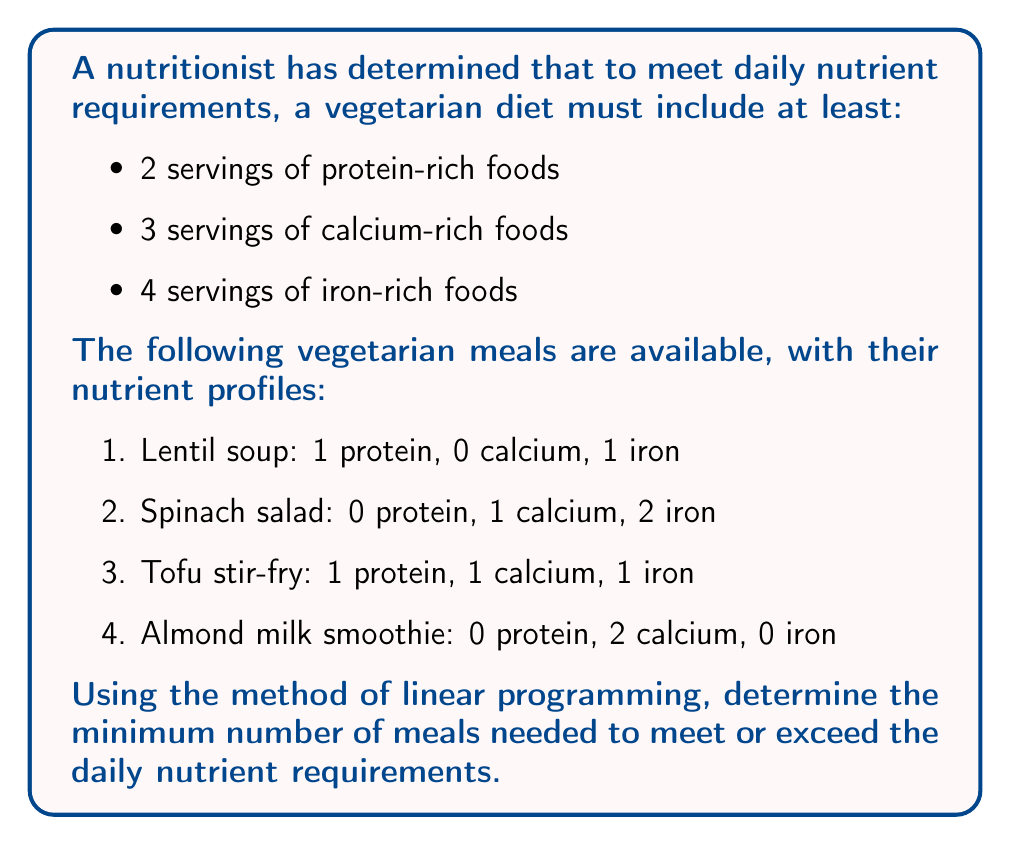What is the answer to this math problem? To solve this problem using linear programming, we need to:

1. Define variables
2. Set up constraints
3. Define the objective function
4. Solve the system

Step 1: Define variables
Let $x_1, x_2, x_3, x_4$ represent the number of servings of lentil soup, spinach salad, tofu stir-fry, and almond milk smoothie, respectively.

Step 2: Set up constraints
Based on the nutrient requirements and meal compositions:

Protein: $x_1 + x_3 \geq 2$
Calcium: $x_2 + x_3 + 2x_4 \geq 3$
Iron: $x_1 + 2x_2 + x_3 \geq 4$

Non-negativity: $x_1, x_2, x_3, x_4 \geq 0$

Step 3: Define the objective function
We want to minimize the total number of meals:

Minimize $Z = x_1 + x_2 + x_3 + x_4$

Step 4: Solve the system
We can solve this system using the simplex method or a linear programming solver. The optimal solution is:

$x_1 = 1, x_2 = 1.5, x_3 = 1, x_4 = 0.25$

This gives us the minimum number of servings for each meal type. However, we need to round up to whole numbers of meals, as we can't serve partial meals.

Rounding up:
$x_1 = 1, x_2 = 2, x_3 = 1, x_4 = 1$

We can verify that this solution meets all nutrient requirements:
Protein: $1 + 1 = 2$ (meets requirement)
Calcium: $2 + 1 + 2 = 5$ (exceeds requirement)
Iron: $1 + 4 + 1 = 6$ (exceeds requirement)

The total number of meals is $1 + 2 + 1 + 1 = 5$.
Answer: The minimum number of vegetarian meals needed to meet daily nutrient requirements is 5. 